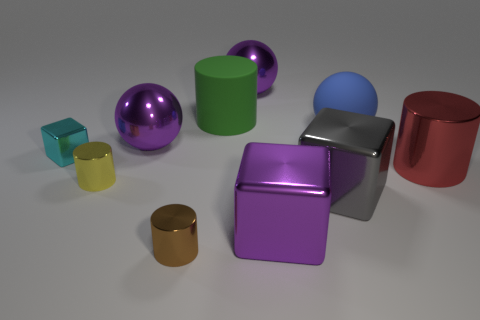What is the shape of the tiny yellow thing that is made of the same material as the red thing?
Offer a very short reply. Cylinder. What is the size of the cylinder in front of the big gray cube?
Keep it short and to the point. Small. What shape is the brown shiny object?
Provide a succinct answer. Cylinder. Does the ball that is to the right of the big gray shiny cube have the same size as the purple metal object that is in front of the red metallic cylinder?
Your answer should be very brief. Yes. How big is the shiny sphere that is right of the metallic object that is in front of the large metal thing in front of the big gray metallic cube?
Your response must be concise. Large. There is a purple object that is in front of the big shiny cylinder that is behind the gray block on the left side of the big rubber ball; what is its shape?
Keep it short and to the point. Cube. What is the shape of the big purple object that is to the left of the small brown thing?
Make the answer very short. Sphere. Are the green object and the big blue sphere on the right side of the cyan metal cube made of the same material?
Keep it short and to the point. Yes. How many other objects are the same shape as the big blue rubber thing?
Your answer should be very brief. 2. What is the shape of the purple object behind the large metallic sphere that is in front of the green thing?
Ensure brevity in your answer.  Sphere. 